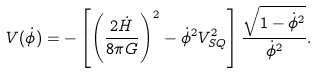<formula> <loc_0><loc_0><loc_500><loc_500>V ( \dot { \phi } ) = - \left [ \left ( \frac { 2 \dot { H } } { 8 \pi G } \right ) ^ { 2 } - \dot { \phi } ^ { 2 } V _ { S Q } ^ { 2 } \right ] \frac { \sqrt { 1 - \dot { \phi } ^ { 2 } } } { \dot { \phi } ^ { 2 } } .</formula> 